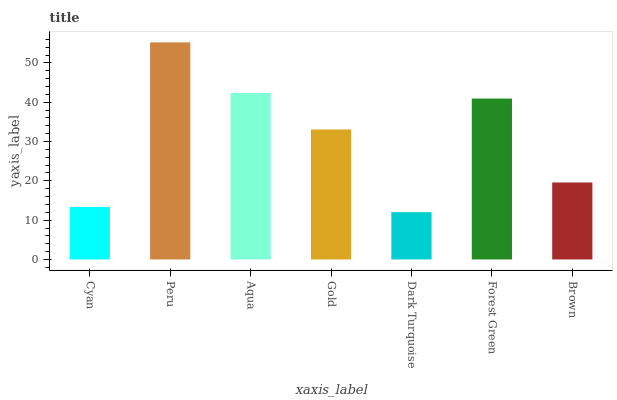Is Dark Turquoise the minimum?
Answer yes or no. Yes. Is Peru the maximum?
Answer yes or no. Yes. Is Aqua the minimum?
Answer yes or no. No. Is Aqua the maximum?
Answer yes or no. No. Is Peru greater than Aqua?
Answer yes or no. Yes. Is Aqua less than Peru?
Answer yes or no. Yes. Is Aqua greater than Peru?
Answer yes or no. No. Is Peru less than Aqua?
Answer yes or no. No. Is Gold the high median?
Answer yes or no. Yes. Is Gold the low median?
Answer yes or no. Yes. Is Aqua the high median?
Answer yes or no. No. Is Dark Turquoise the low median?
Answer yes or no. No. 